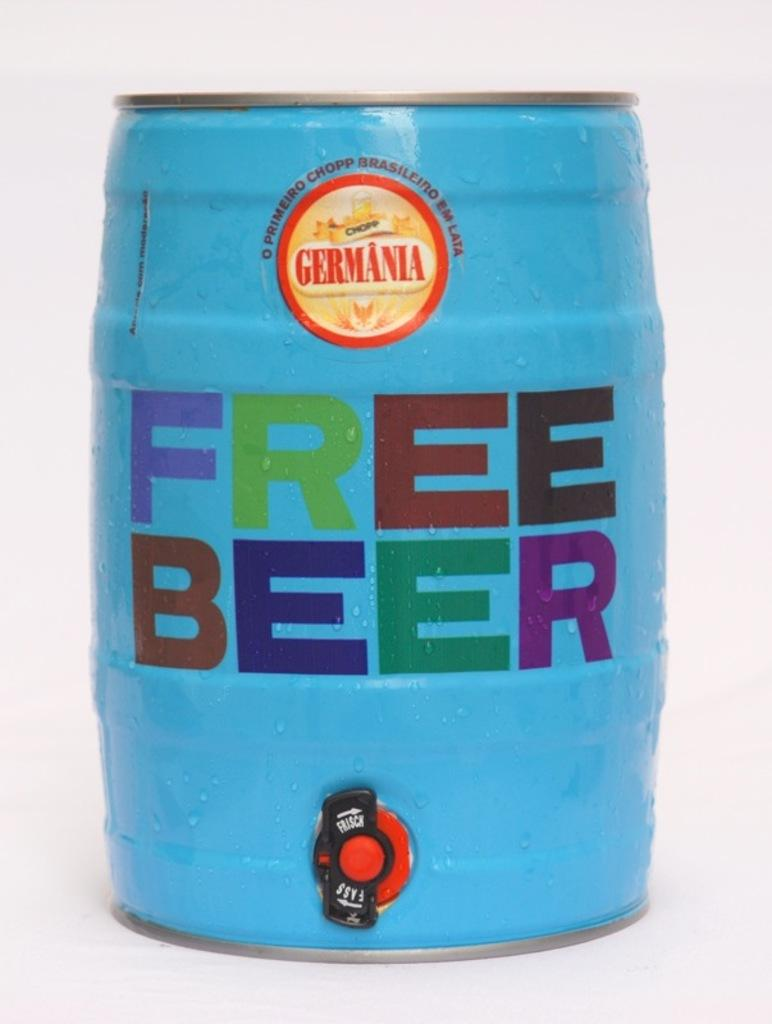<image>
Give a short and clear explanation of the subsequent image. The blue barrel shown is advertising free beer. 